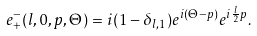Convert formula to latex. <formula><loc_0><loc_0><loc_500><loc_500>e _ { + } ^ { - } ( l , 0 , p , \Theta ) = i ( 1 - \delta _ { l , 1 } ) e ^ { i ( \Theta - p ) } e ^ { i \frac { l } { 2 } p } .</formula> 